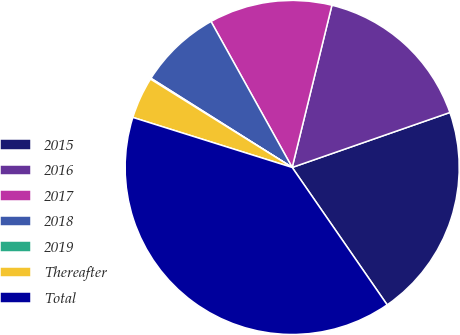<chart> <loc_0><loc_0><loc_500><loc_500><pie_chart><fcel>2015<fcel>2016<fcel>2017<fcel>2018<fcel>2019<fcel>Thereafter<fcel>Total<nl><fcel>20.71%<fcel>15.84%<fcel>11.9%<fcel>7.96%<fcel>0.09%<fcel>4.03%<fcel>39.47%<nl></chart> 